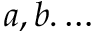Convert formula to latex. <formula><loc_0><loc_0><loc_500><loc_500>a , b . \dots</formula> 